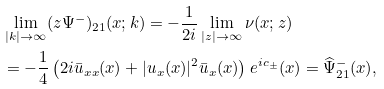Convert formula to latex. <formula><loc_0><loc_0><loc_500><loc_500>& \lim _ { | k | \rightarrow \infty } ( z \Psi ^ { - } ) _ { 2 1 } ( x ; k ) = - \frac { 1 } { 2 i } \lim _ { | z | \rightarrow \infty } \nu ( x ; z ) \\ & = - \frac { 1 } { 4 } \left ( 2 i \bar { u } _ { x x } ( x ) + | u _ { x } ( x ) | ^ { 2 } \bar { u } _ { x } ( x ) \right ) e ^ { i c _ { \pm } } ( x ) = \widehat { \Psi } ^ { - } _ { 2 1 } ( x ) ,</formula> 